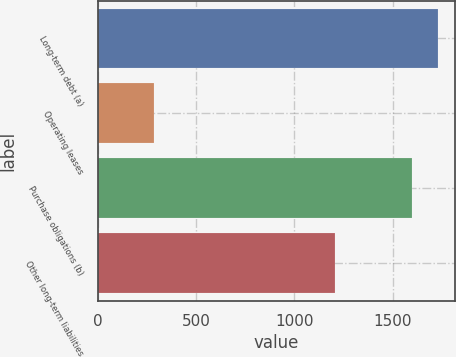Convert chart. <chart><loc_0><loc_0><loc_500><loc_500><bar_chart><fcel>Long-term debt (a)<fcel>Operating leases<fcel>Purchase obligations (b)<fcel>Other long-term liabilities<nl><fcel>1731.3<fcel>284<fcel>1599<fcel>1209<nl></chart> 